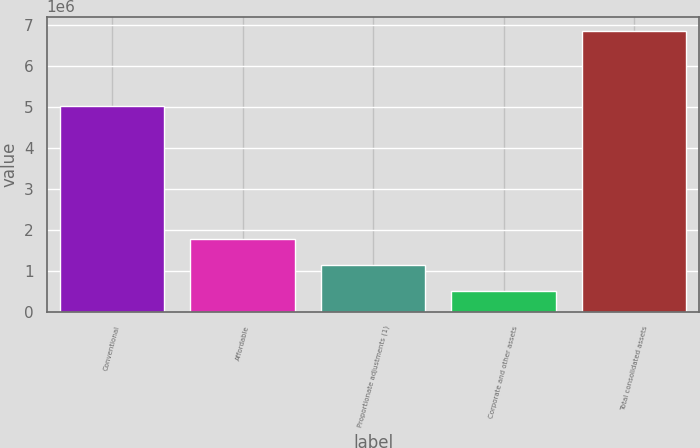Convert chart. <chart><loc_0><loc_0><loc_500><loc_500><bar_chart><fcel>Conventional<fcel>Affordable<fcel>Proportionate adjustments (1)<fcel>Corporate and other assets<fcel>Total consolidated assets<nl><fcel>5.03186e+06<fcel>1.78342e+06<fcel>1.14736e+06<fcel>511306<fcel>6.87186e+06<nl></chart> 